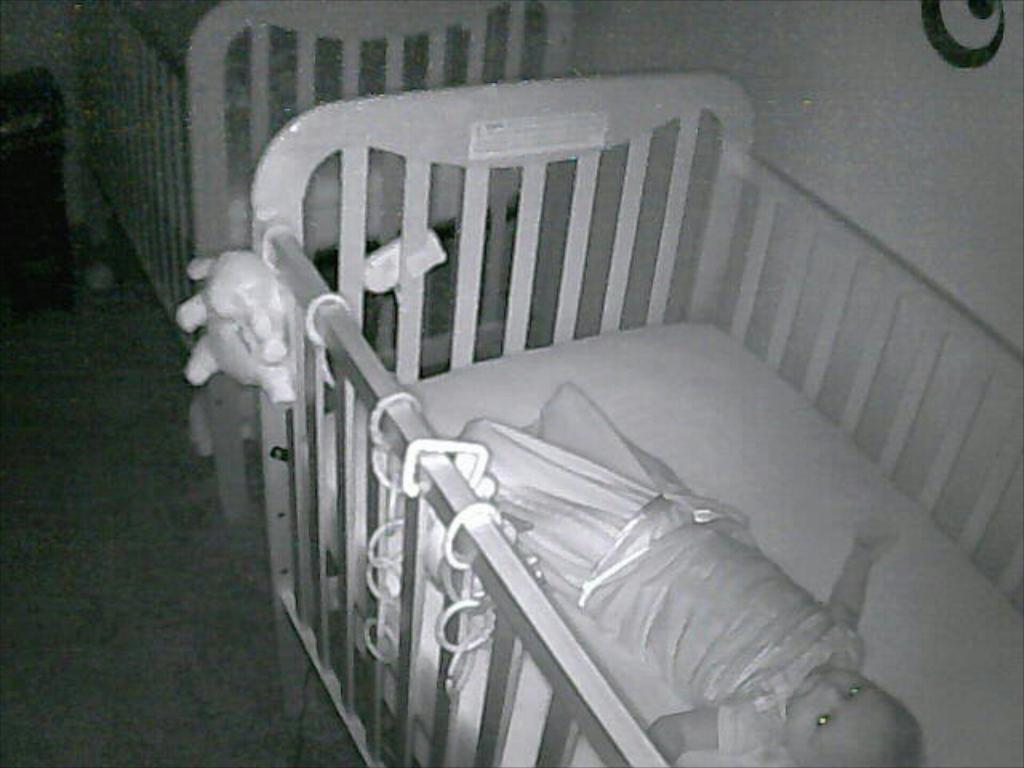In one or two sentences, can you explain what this image depicts? In this image I can see two babies bed on the floor and a baby is lying on it. In the background I can see a wall and a table. This image is taken in a room. 